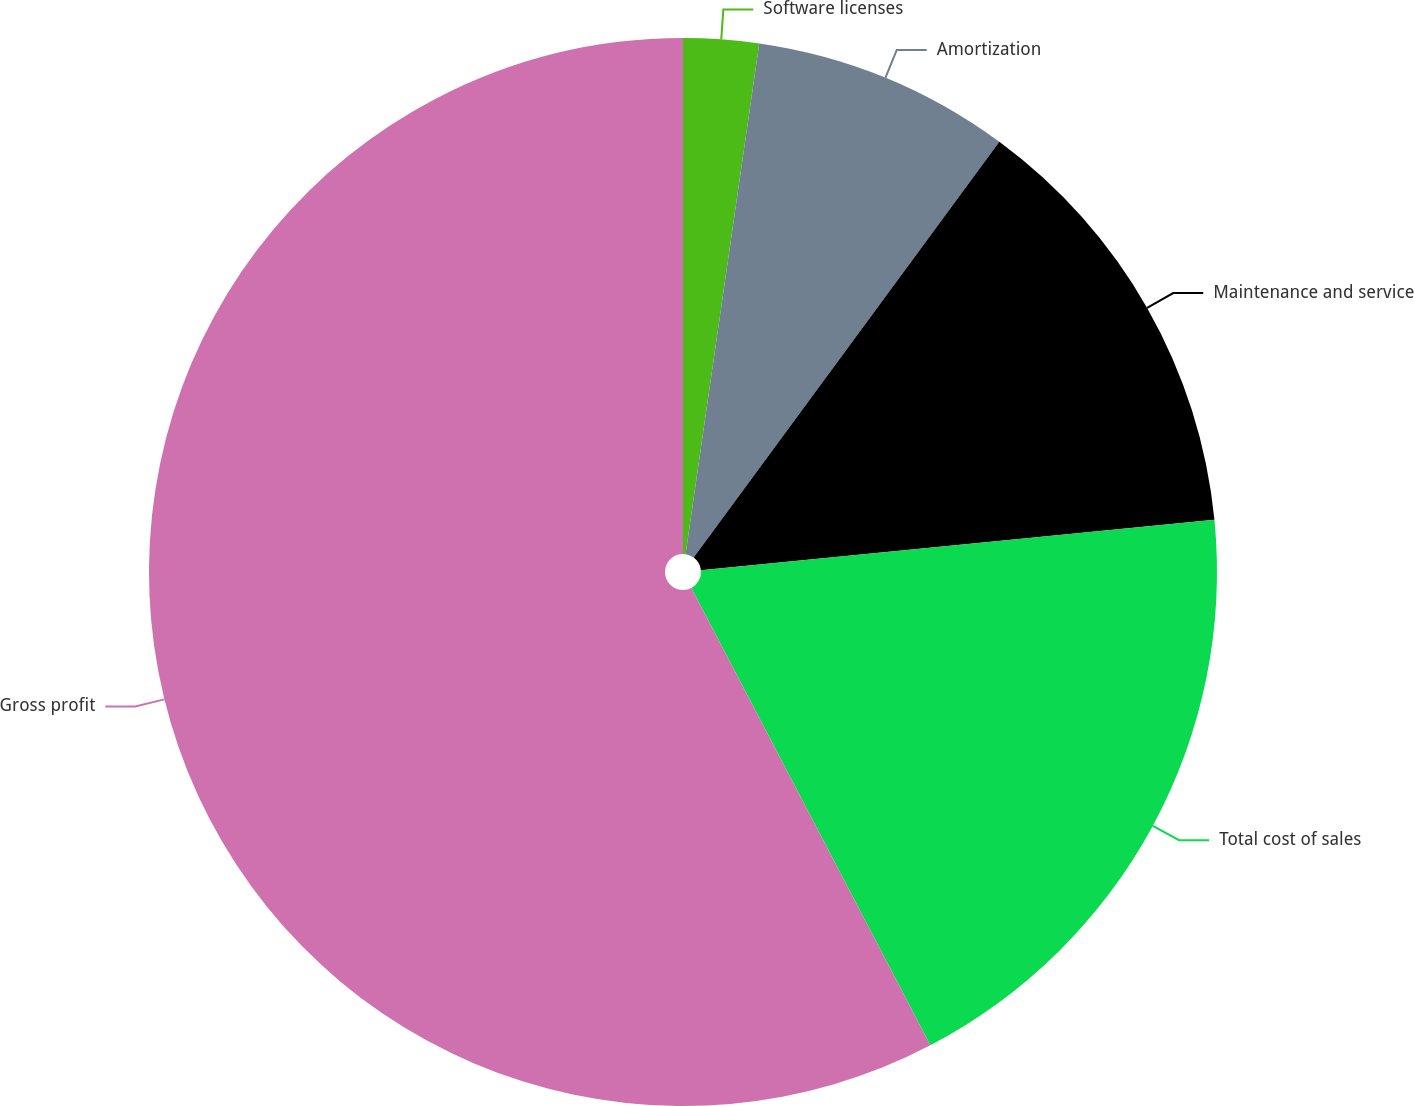Convert chart to OTSL. <chart><loc_0><loc_0><loc_500><loc_500><pie_chart><fcel>Software licenses<fcel>Amortization<fcel>Maintenance and service<fcel>Total cost of sales<fcel>Gross profit<nl><fcel>2.28%<fcel>7.81%<fcel>13.35%<fcel>18.89%<fcel>57.66%<nl></chart> 